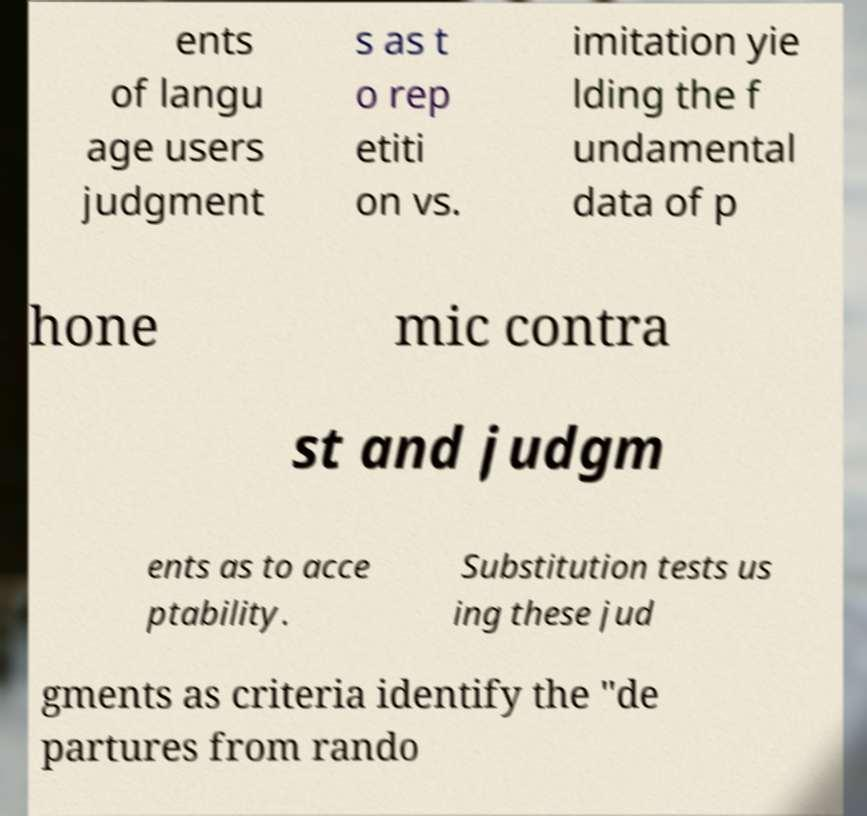Please read and relay the text visible in this image. What does it say? ents of langu age users judgment s as t o rep etiti on vs. imitation yie lding the f undamental data of p hone mic contra st and judgm ents as to acce ptability. Substitution tests us ing these jud gments as criteria identify the "de partures from rando 